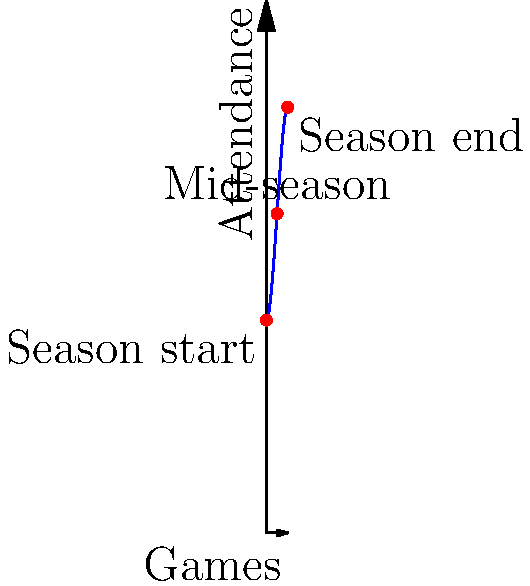The attendance at Daskalakis Athletic Center over a basketball season can be modeled by the function $f(x) = -0.2x^3 + 3x^2 + 100$, where $x$ represents the number of games played (0-10) and $f(x)$ represents the attendance in hundreds. Calculate the total attendance for the season by finding the area under this curve from $x=0$ to $x=10$. To find the total attendance for the season, we need to calculate the definite integral of the given function from 0 to 10.

1) The function is $f(x) = -0.2x^3 + 3x^2 + 100$

2) We need to integrate this function from 0 to 10:

   $$\int_0^{10} (-0.2x^3 + 3x^2 + 100) dx$$

3) Integrate each term:
   $$\left[-0.05x^4 + x^3 + 100x\right]_0^{10}$$

4) Evaluate at the upper and lower bounds:
   $$(-0.05(10^4) + (10^3) + 100(10)) - (-0.05(0^4) + (0^3) + 100(0))$$

5) Simplify:
   $$(-5000 + 1000 + 1000) - (0)$$
   $$= -3000 + 1000$$
   $$= -2000$$

6) Remember that the attendance was in hundreds, so multiply by 100:
   $$-2000 * 100 = -200,000$$

7) The negative value doesn't make sense for attendance, so we take the absolute value:
   $$||-200,000|| = 200,000$$

Therefore, the total attendance for the season is 200,000 people.
Answer: 200,000 people 